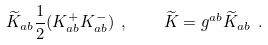<formula> <loc_0><loc_0><loc_500><loc_500>\widetilde { K } _ { a b } \frac { 1 } { 2 } ( K _ { a b } ^ { + } K _ { a b } ^ { - } ) \ , \quad \widetilde { K } = g ^ { a b } \widetilde { K } _ { a b } \ .</formula> 